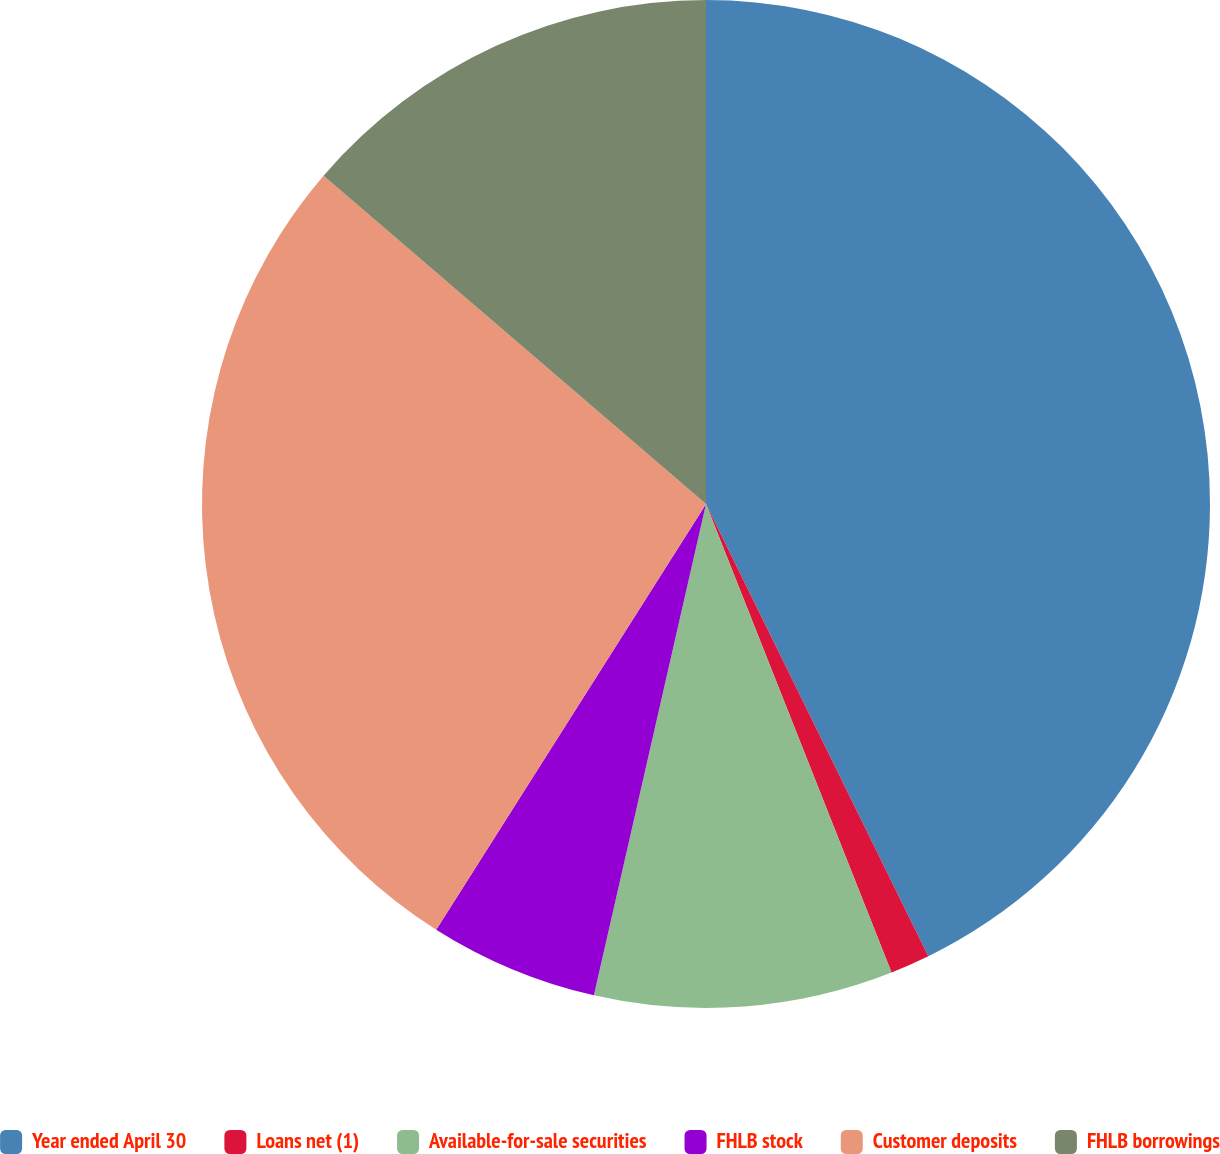Convert chart to OTSL. <chart><loc_0><loc_0><loc_500><loc_500><pie_chart><fcel>Year ended April 30<fcel>Loans net (1)<fcel>Available-for-sale securities<fcel>FHLB stock<fcel>Customer deposits<fcel>FHLB borrowings<nl><fcel>42.73%<fcel>1.27%<fcel>9.57%<fcel>5.42%<fcel>27.3%<fcel>13.71%<nl></chart> 